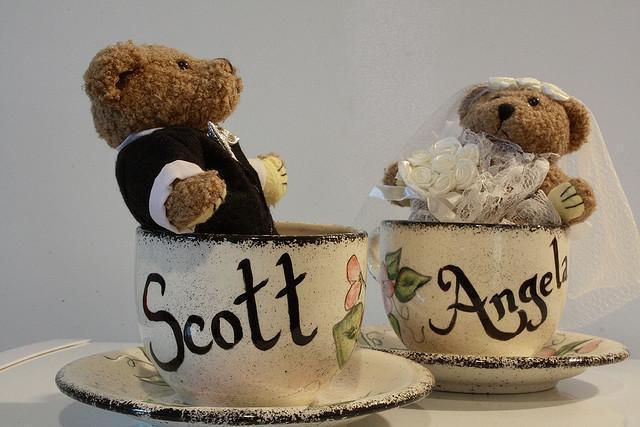How many teddy bears can be seen?
Give a very brief answer. 2. How many train cars are there?
Give a very brief answer. 0. 